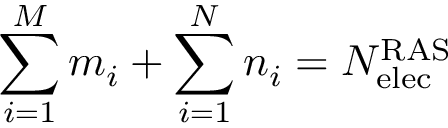<formula> <loc_0><loc_0><loc_500><loc_500>\sum _ { i = 1 } ^ { M } m _ { i } + \sum _ { i = 1 } ^ { N } n _ { i } = N _ { e l e c } ^ { R A S }</formula> 